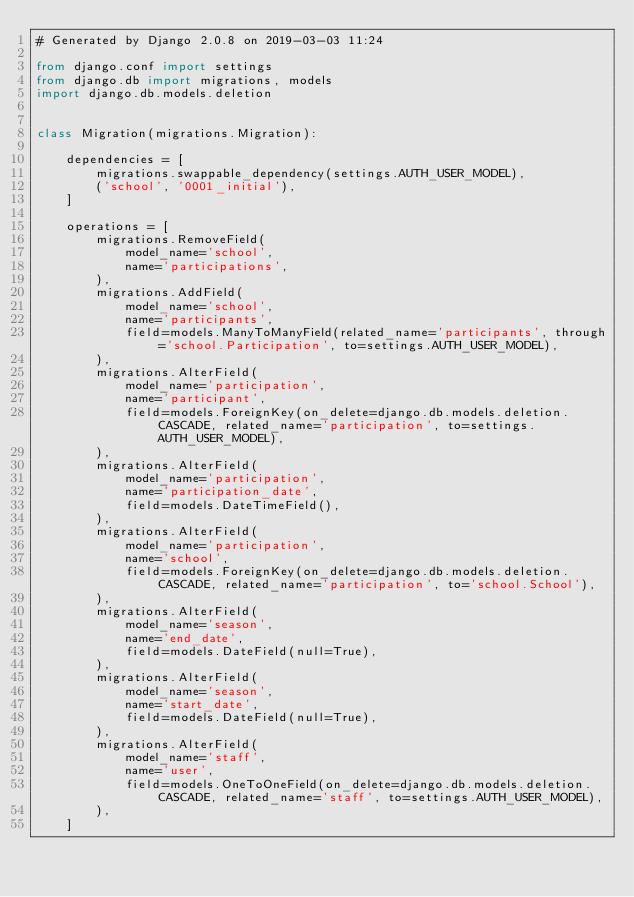Convert code to text. <code><loc_0><loc_0><loc_500><loc_500><_Python_># Generated by Django 2.0.8 on 2019-03-03 11:24

from django.conf import settings
from django.db import migrations, models
import django.db.models.deletion


class Migration(migrations.Migration):

    dependencies = [
        migrations.swappable_dependency(settings.AUTH_USER_MODEL),
        ('school', '0001_initial'),
    ]

    operations = [
        migrations.RemoveField(
            model_name='school',
            name='participations',
        ),
        migrations.AddField(
            model_name='school',
            name='participants',
            field=models.ManyToManyField(related_name='participants', through='school.Participation', to=settings.AUTH_USER_MODEL),
        ),
        migrations.AlterField(
            model_name='participation',
            name='participant',
            field=models.ForeignKey(on_delete=django.db.models.deletion.CASCADE, related_name='participation', to=settings.AUTH_USER_MODEL),
        ),
        migrations.AlterField(
            model_name='participation',
            name='participation_date',
            field=models.DateTimeField(),
        ),
        migrations.AlterField(
            model_name='participation',
            name='school',
            field=models.ForeignKey(on_delete=django.db.models.deletion.CASCADE, related_name='participation', to='school.School'),
        ),
        migrations.AlterField(
            model_name='season',
            name='end_date',
            field=models.DateField(null=True),
        ),
        migrations.AlterField(
            model_name='season',
            name='start_date',
            field=models.DateField(null=True),
        ),
        migrations.AlterField(
            model_name='staff',
            name='user',
            field=models.OneToOneField(on_delete=django.db.models.deletion.CASCADE, related_name='staff', to=settings.AUTH_USER_MODEL),
        ),
    ]
</code> 